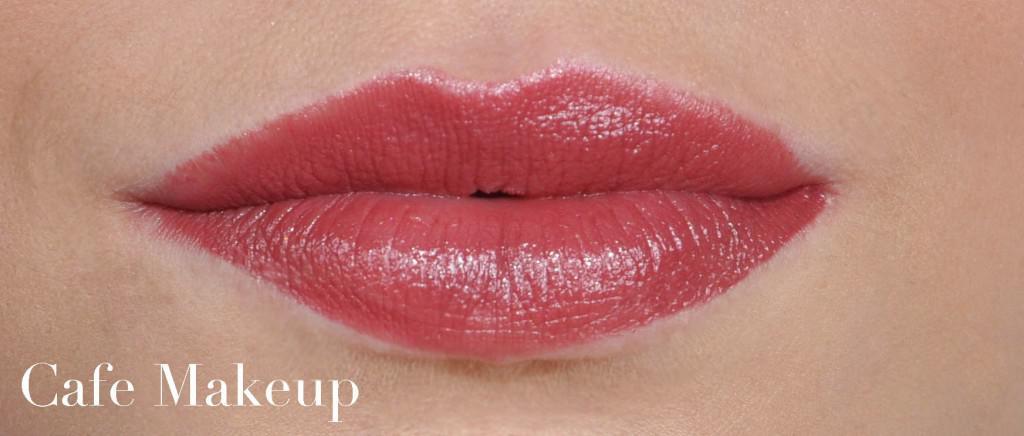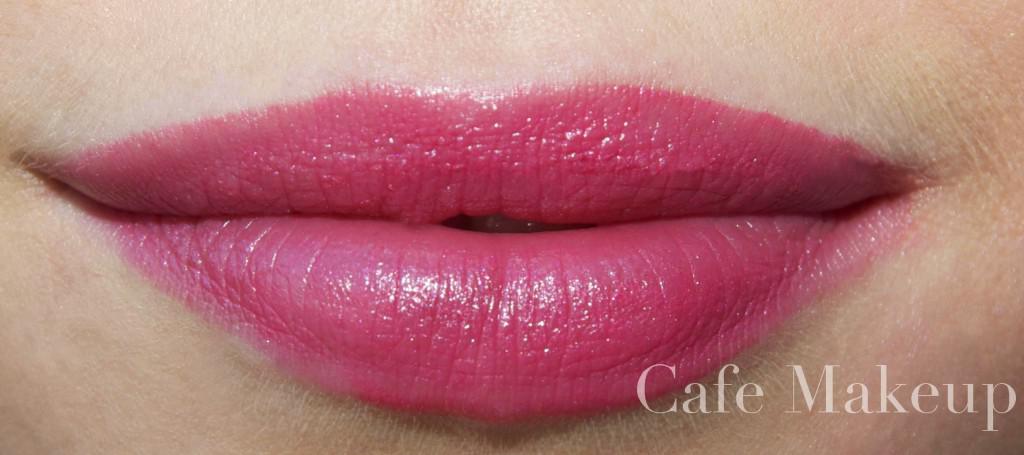The first image is the image on the left, the second image is the image on the right. Examine the images to the left and right. Is the description "The lips on the right have a more lavender tint than the lips on the left, which are more coral colored." accurate? Answer yes or no. Yes. 